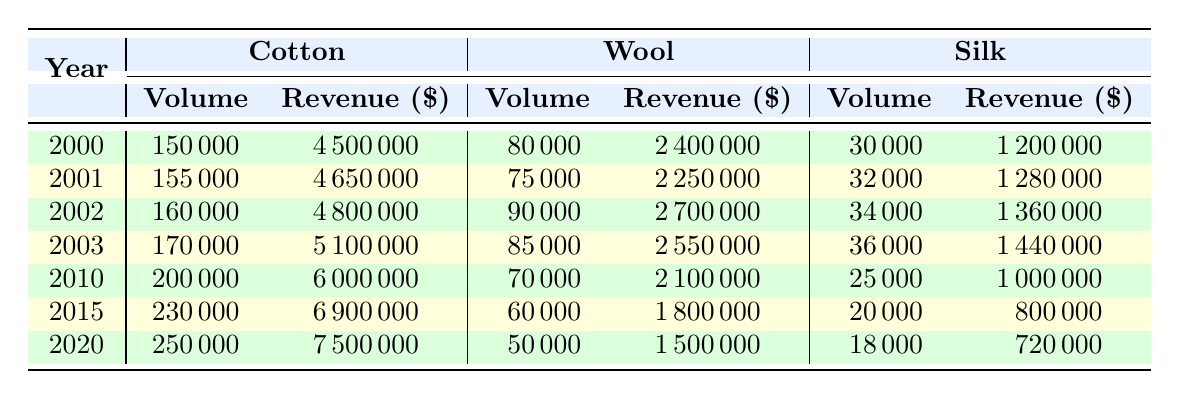What was the total sales volume of Cotton in 2010? The sales volume of Cotton in 2010 is directly provided in the table as 200,000.
Answer: 200000 What is the revenue generated from Wool sales in 2020? The revenue from Wool sales in 2020 is given in the table as 1,500,000.
Answer: 1500000 What was the increase in sales volume of Silk from 2000 to 2003? The sales volume of Silk in 2000 was 30,000 and in 2003 it was 36,000. The increase is calculated as 36,000 - 30,000 = 6,000.
Answer: 6000 What years saw a sales volume of Cotton greater than 200,000? According to the table, Cotton's sales volume was greater than 200,000 in 2015 (230,000) and 2020 (250,000).
Answer: 2015 and 2020 What was the average revenue generated from all fabric types in 2015? The revenues in 2015 are 6,900,000 (Cotton), 1,800,000 (Wool), and 800,000 (Silk). Their total is 6,900,000 + 1,800,000 + 800,000 = 9,500,000. Dividing by 3 gives the average of 9,500,000 / 3 = 3,166,667.
Answer: 3166667 Was the revenue from Wool higher in 2015 or 2020? The revenue from Wool in 2015 was 1,800,000 and in 2020 it was 1,500,000. Comparing these values shows that 1,800,000 is greater than 1,500,000.
Answer: Yes How much did the revenue from Silk decrease from 2010 to 2020? The revenue from Silk was 1,000,000 in 2010 and decreased to 720,000 in 2020. The decrease is calculated as 1,000,000 - 720,000 = 280,000.
Answer: 280000 In which year did Cotton have the highest revenue? By examining the revenues for Cotton over the years, we see that it was highest in 2020 at 7,500,000.
Answer: 2020 What is the total sales volume for all fabric types in 2002? The sales volumes for all fabric types in 2002 are Cotton (160,000), Wool (90,000), and Silk (34,000). Summing these gives 160,000 + 90,000 + 34,000 = 284,000.
Answer: 284000 Did the sales volume of Wool increase every year from 2000 to 2020? The sales volumes for Wool in the years 2000, 2001, 2002, 2003, 2010, 2015, and 2020 are 80,000, 75,000, 90,000, 85,000, 70,000, 60,000, and 50,000 respectively. Observing these figures shows that it did not increase every year as it decreased in several years.
Answer: No 